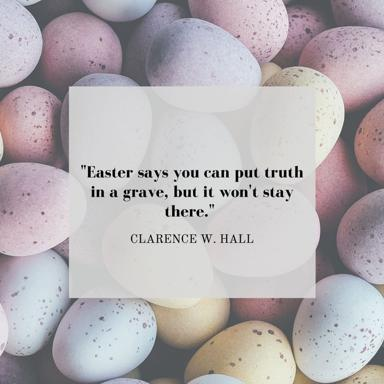What does the quote by Clarence W. Hall mean? The quote "Easter says you can put truth in a grave, but it won't stay there" by Clarence W. Hall captures the essence of the inexorable nature of truth. Easter, a cornerstone of Christian belief, commemorates the resurrection of Jesus Christ, symbolizing not only the victory of life over death but also of truth over suppression. Hall's words suggest a broader philosophical reflection that truth, regardless of efforts to obscure it, eventually prevails. This principle can be observed in various aspects of life and human history, making the quote versatile and reflective. 